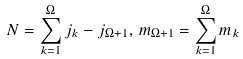<formula> <loc_0><loc_0><loc_500><loc_500>N = \sum _ { k = 1 } ^ { \Omega } j _ { k } - j _ { \Omega + 1 } , \, m _ { \Omega + 1 } = \sum _ { k = 1 } ^ { \Omega } m _ { k }</formula> 